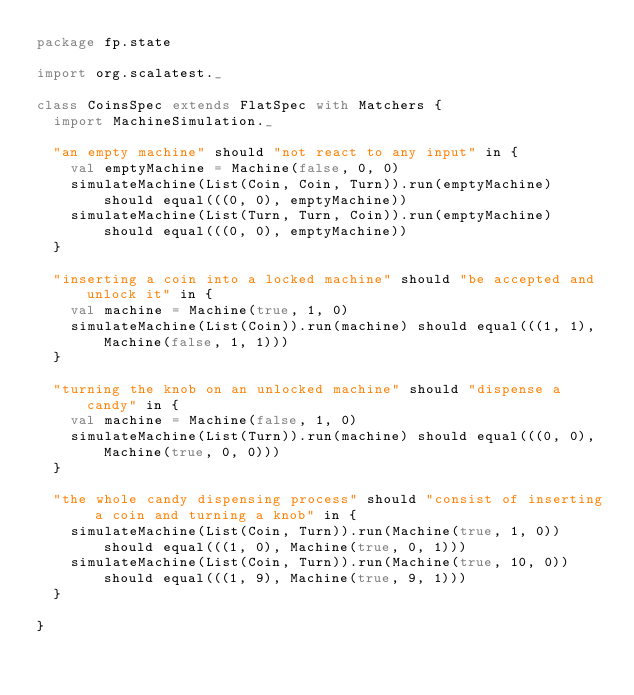Convert code to text. <code><loc_0><loc_0><loc_500><loc_500><_Scala_>package fp.state

import org.scalatest._

class CoinsSpec extends FlatSpec with Matchers {
  import MachineSimulation._

  "an empty machine" should "not react to any input" in {
    val emptyMachine = Machine(false, 0, 0)
    simulateMachine(List(Coin, Coin, Turn)).run(emptyMachine) should equal(((0, 0), emptyMachine))
    simulateMachine(List(Turn, Turn, Coin)).run(emptyMachine) should equal(((0, 0), emptyMachine))
  }

  "inserting a coin into a locked machine" should "be accepted and unlock it" in {
    val machine = Machine(true, 1, 0)
    simulateMachine(List(Coin)).run(machine) should equal(((1, 1), Machine(false, 1, 1)))
  }

  "turning the knob on an unlocked machine" should "dispense a candy" in {
    val machine = Machine(false, 1, 0)
    simulateMachine(List(Turn)).run(machine) should equal(((0, 0), Machine(true, 0, 0)))
  }

  "the whole candy dispensing process" should "consist of inserting a coin and turning a knob" in {
    simulateMachine(List(Coin, Turn)).run(Machine(true, 1, 0)) should equal(((1, 0), Machine(true, 0, 1)))
    simulateMachine(List(Coin, Turn)).run(Machine(true, 10, 0)) should equal(((1, 9), Machine(true, 9, 1)))
  }

}
</code> 